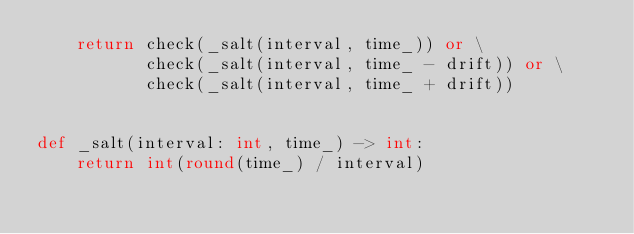<code> <loc_0><loc_0><loc_500><loc_500><_Python_>    return check(_salt(interval, time_)) or \
           check(_salt(interval, time_ - drift)) or \
           check(_salt(interval, time_ + drift))


def _salt(interval: int, time_) -> int:
    return int(round(time_) / interval)
</code> 